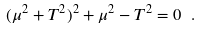<formula> <loc_0><loc_0><loc_500><loc_500>( \mu ^ { 2 } + T ^ { 2 } ) ^ { 2 } + \mu ^ { 2 } - T ^ { 2 } = 0 \ .</formula> 